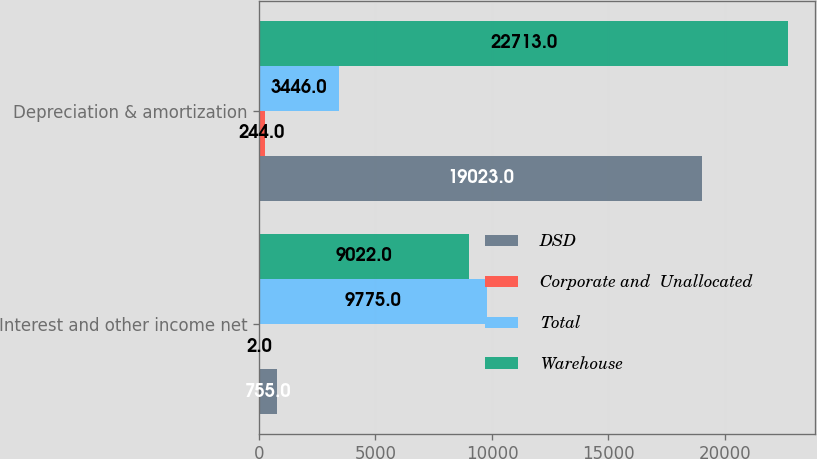Convert chart to OTSL. <chart><loc_0><loc_0><loc_500><loc_500><stacked_bar_chart><ecel><fcel>Interest and other income net<fcel>Depreciation & amortization<nl><fcel>DSD<fcel>755<fcel>19023<nl><fcel>Corporate and  Unallocated<fcel>2<fcel>244<nl><fcel>Total<fcel>9775<fcel>3446<nl><fcel>Warehouse<fcel>9022<fcel>22713<nl></chart> 